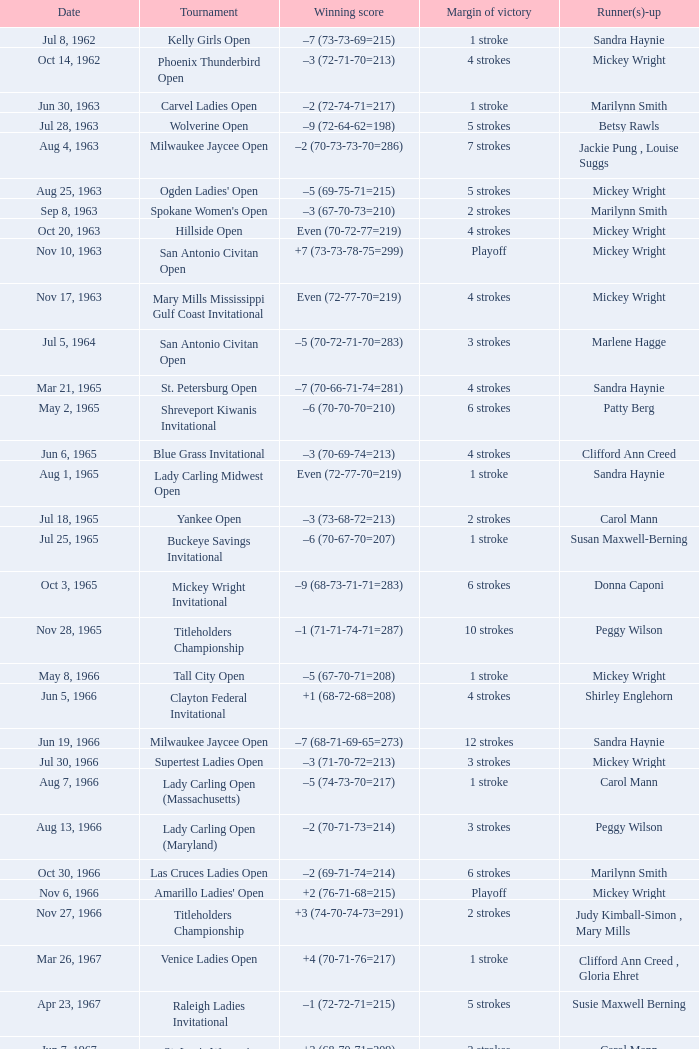What was the victorious score with a 9-stroke lead? –7 (73-68-73-67=281). 